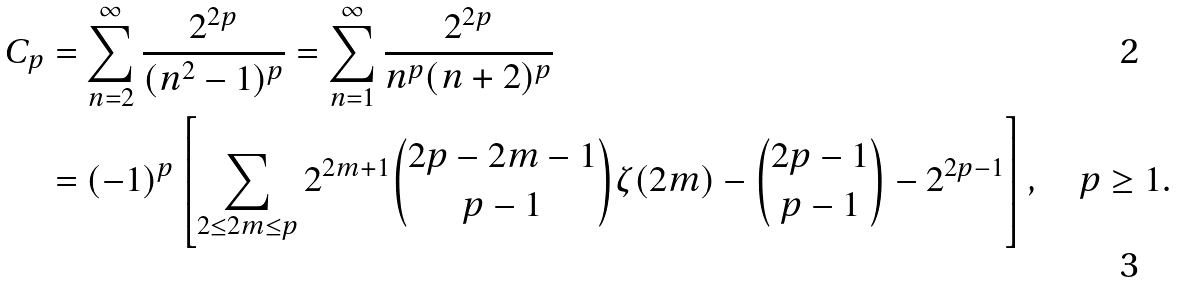<formula> <loc_0><loc_0><loc_500><loc_500>C _ { p } & = \sum _ { n = 2 } ^ { \infty } \frac { 2 ^ { 2 p } } { ( n ^ { 2 } - 1 ) ^ { p } } = \sum _ { n = 1 } ^ { \infty } \frac { 2 ^ { 2 p } } { n ^ { p } ( n + 2 ) ^ { p } } \\ & = ( - 1 ) ^ { p } \left [ \sum _ { 2 \leq 2 m \leq p } 2 ^ { 2 m + 1 } \binom { 2 p - 2 m - 1 } { p - 1 } \zeta ( 2 m ) - \binom { 2 p - 1 } { p - 1 } - 2 ^ { 2 p - 1 } \right ] , \quad p \geq 1 .</formula> 